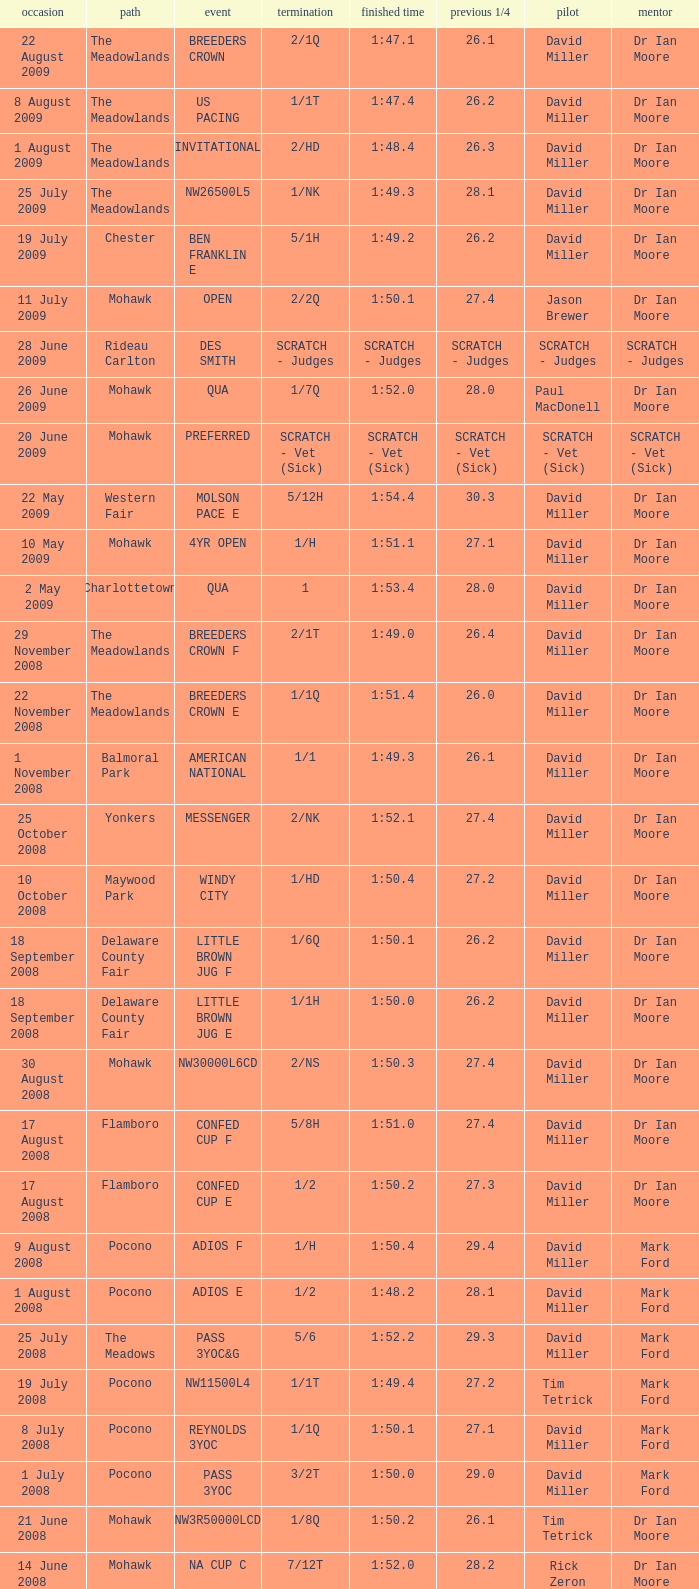What is the last 1/4 for the QUA race with a finishing time of 2:03.1? 29.2. 